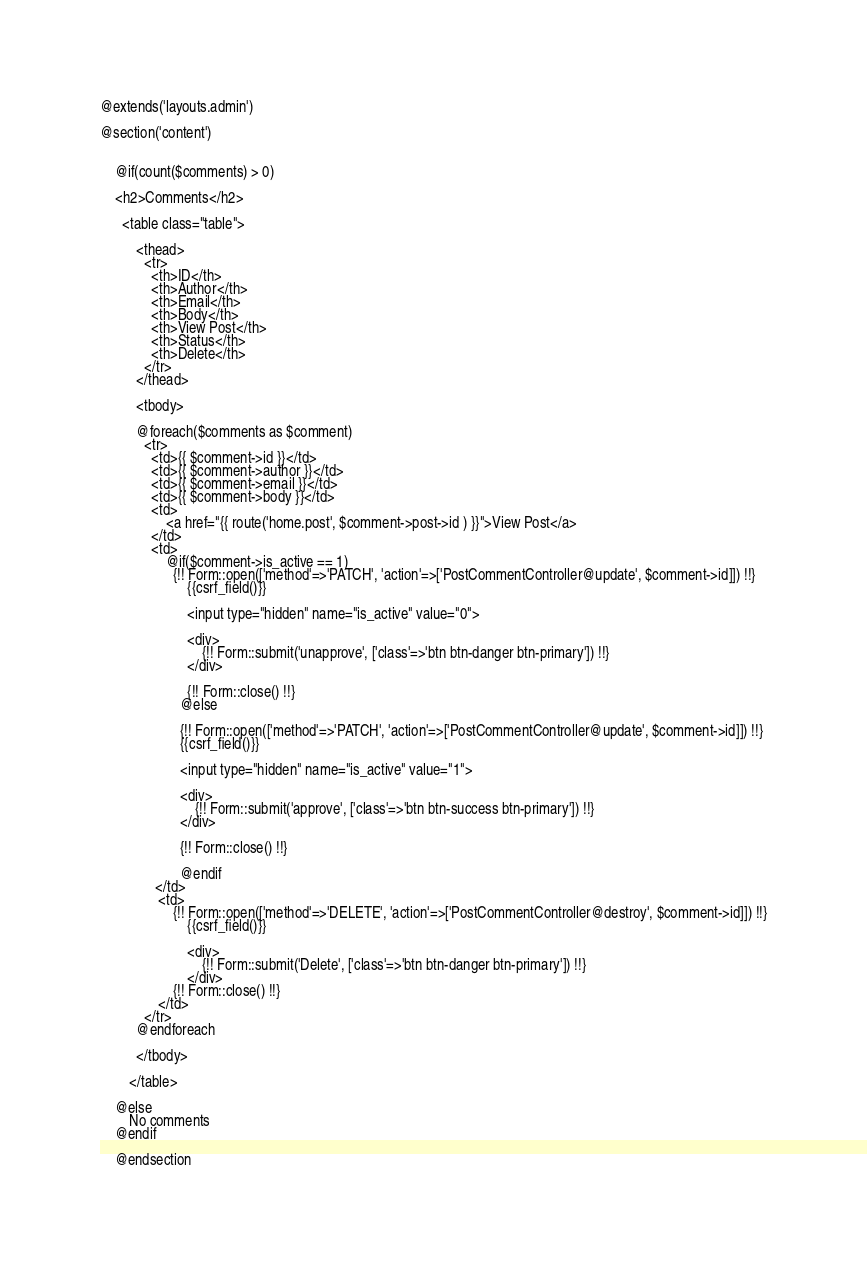Convert code to text. <code><loc_0><loc_0><loc_500><loc_500><_PHP_>@extends('layouts.admin')

@section('content')


    @if(count($comments) > 0)

    <h2>Comments</h2>

      <table class="table">

          <thead>
            <tr>
              <th>ID</th>
              <th>Author</th>
              <th>Email</th>
              <th>Body</th>
              <th>View Post</th>
              <th>Status</th>
              <th>Delete</th>
            </tr>
          </thead>

          <tbody>

          @foreach($comments as $comment)
            <tr>
              <td>{{ $comment->id }}</td>
              <td>{{ $comment->author }}</td>
              <td>{{ $comment->email }}</td>
              <td>{{ $comment->body }}</td>
              <td>
                  <a href="{{ route('home.post', $comment->post->id ) }}">View Post</a>
              </td>
              <td>
                  @if($comment->is_active == 1)
                    {!! Form::open(['method'=>'PATCH', 'action'=>['PostCommentController@update', $comment->id]]) !!}
                        {{csrf_field()}}

                        <input type="hidden" name="is_active" value="0">

                        <div>
                            {!! Form::submit('unapprove', ['class'=>'btn btn-danger btn-primary']) !!}
                        </div>

                        {!! Form::close() !!}
                      @else

                      {!! Form::open(['method'=>'PATCH', 'action'=>['PostCommentController@update', $comment->id]]) !!}
                      {{csrf_field()}}

                      <input type="hidden" name="is_active" value="1">

                      <div>
                          {!! Form::submit('approve', ['class'=>'btn btn-success btn-primary']) !!}
                      </div>

                      {!! Form::close() !!}

                      @endif
               </td>
                <td>
                    {!! Form::open(['method'=>'DELETE', 'action'=>['PostCommentController@destroy', $comment->id]]) !!}
                        {{csrf_field()}}

                        <div>
                            {!! Form::submit('Delete', ['class'=>'btn btn-danger btn-primary']) !!}
                        </div>
                    {!! Form::close() !!}
                </td>
            </tr>
          @endforeach

          </tbody>

        </table>

    @else
        No comments
    @endif

    @endsection</code> 